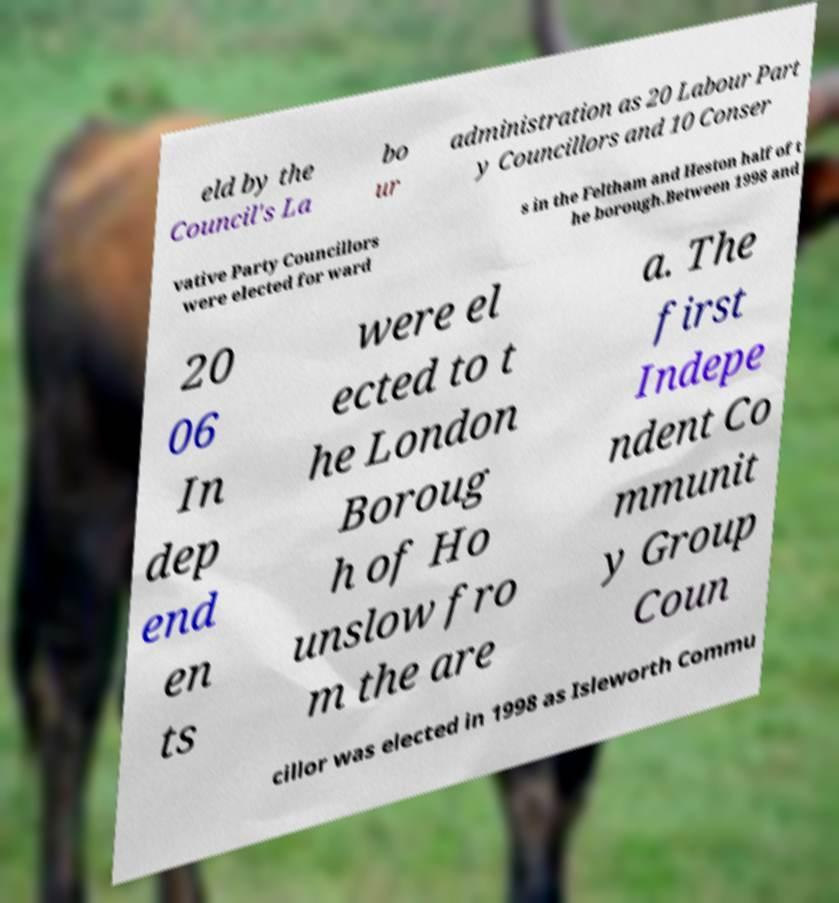There's text embedded in this image that I need extracted. Can you transcribe it verbatim? eld by the Council's La bo ur administration as 20 Labour Part y Councillors and 10 Conser vative Party Councillors were elected for ward s in the Feltham and Heston half of t he borough.Between 1998 and 20 06 In dep end en ts were el ected to t he London Boroug h of Ho unslow fro m the are a. The first Indepe ndent Co mmunit y Group Coun cillor was elected in 1998 as Isleworth Commu 